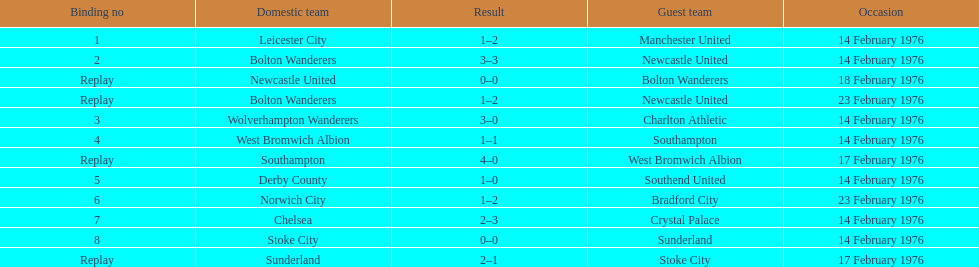How many games were replays? 4. 